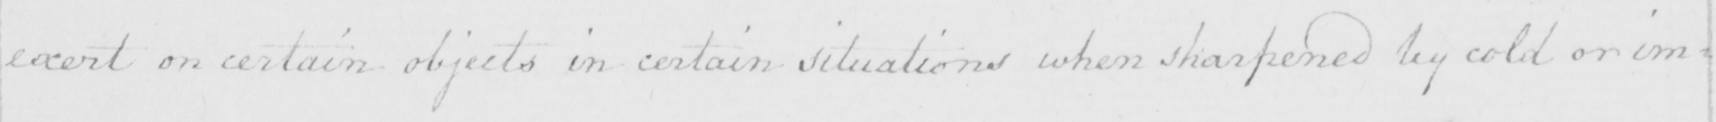What text is written in this handwritten line? exert on certain objects in certain situations when sharpened by cold or im= 